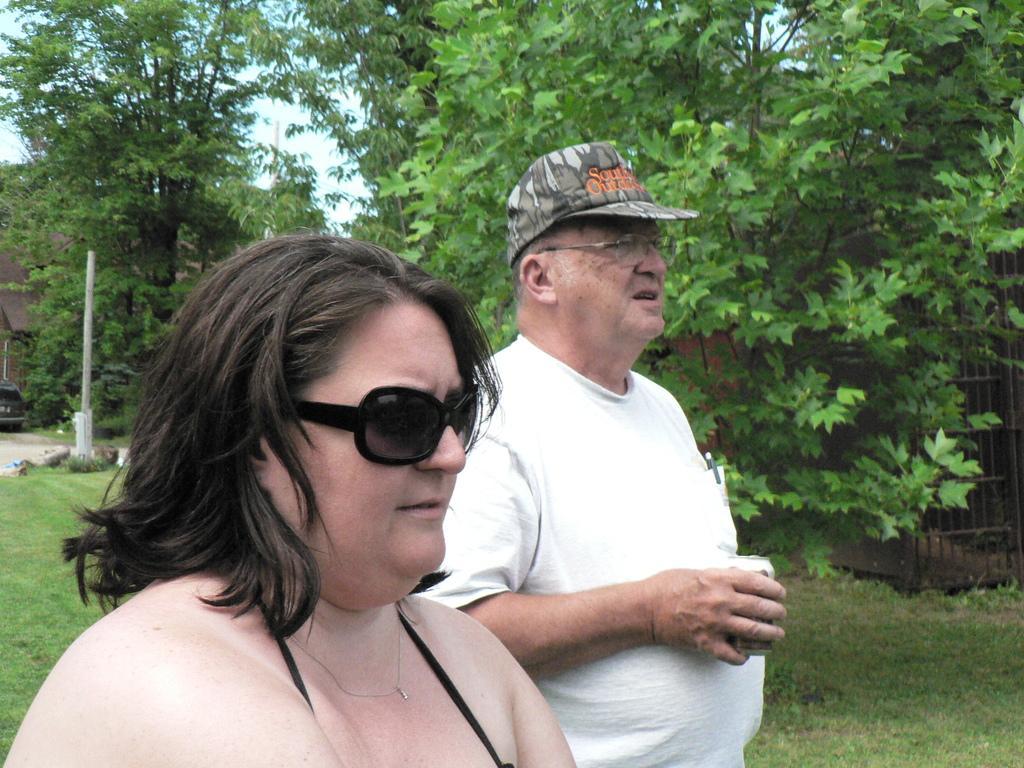How would you summarize this image in a sentence or two? In the image we can see there are people standing and the woman is wearing sunglasses and the man is wearing cap. He is holding the juice can and the ground is covered with grass. Behind there are lot of trees. 